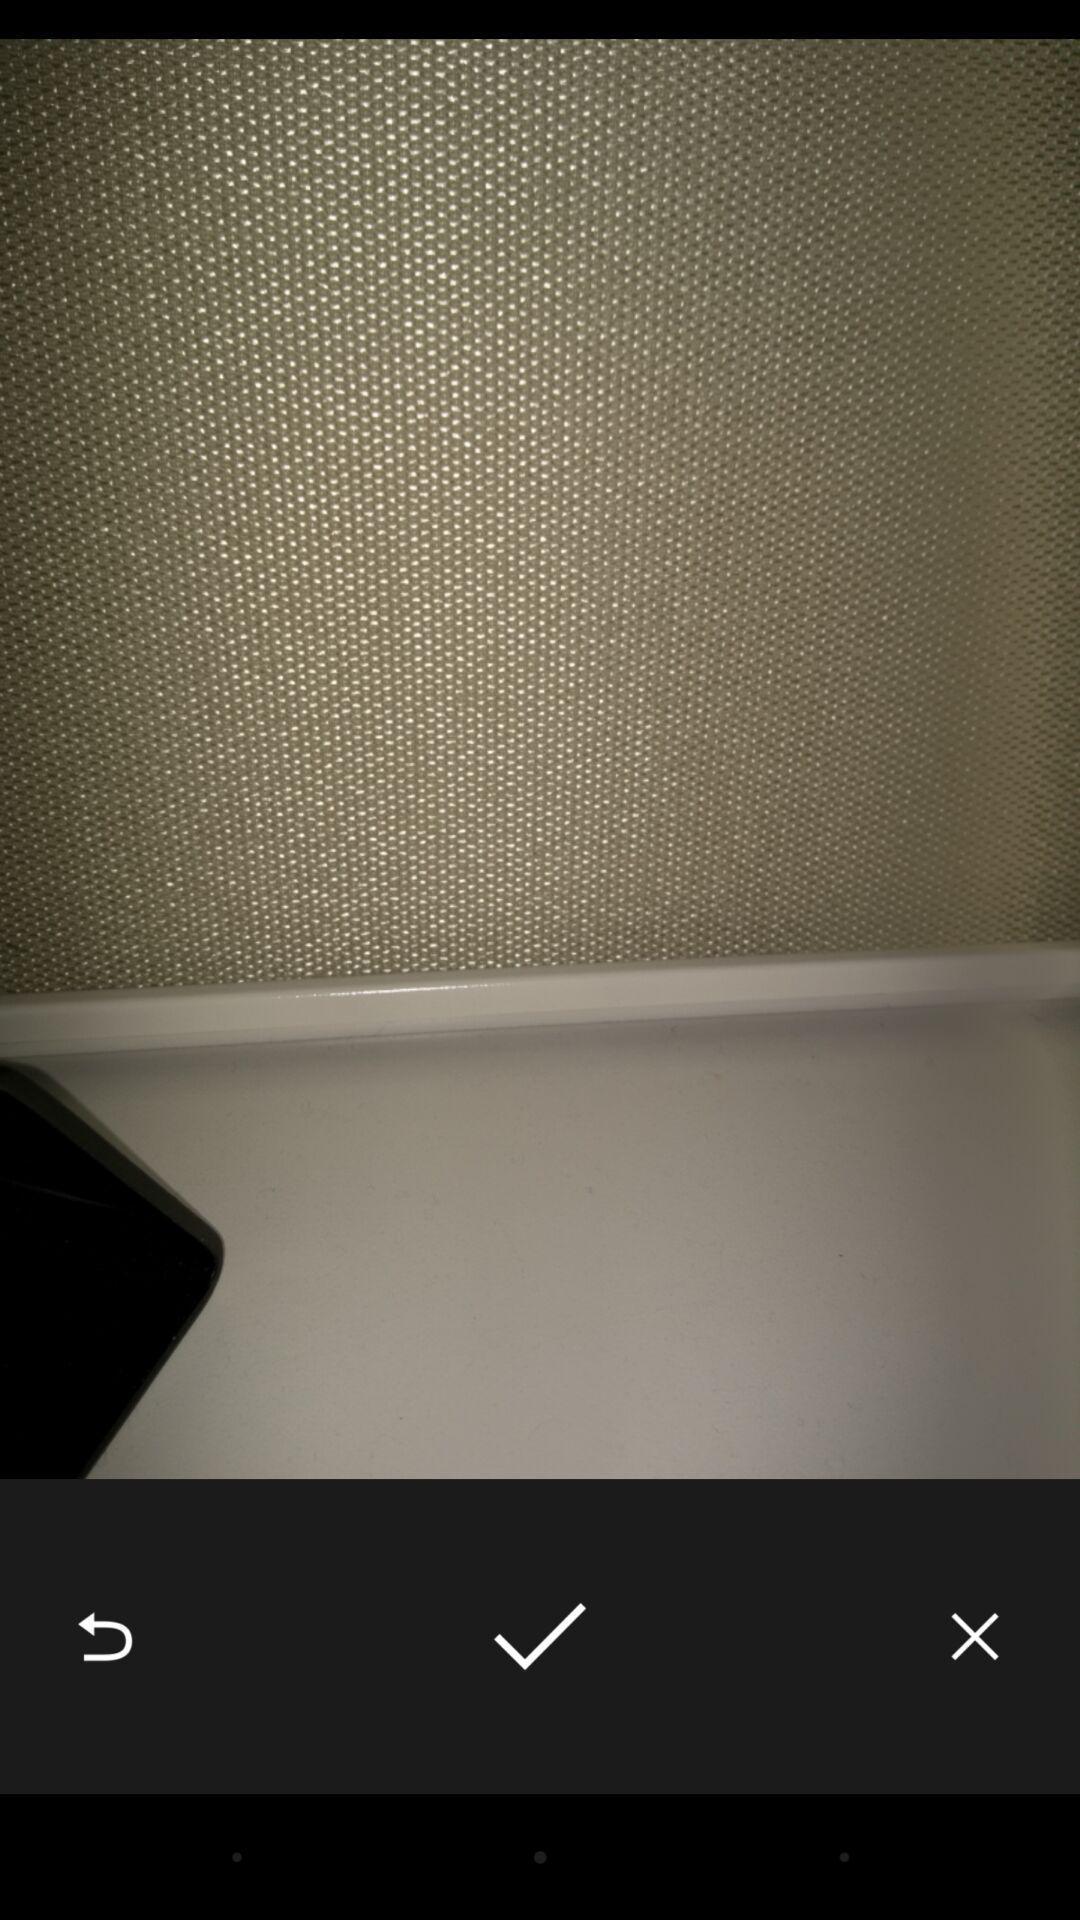Provide a detailed account of this screenshot. Screen displaying the picture taken from camera. 